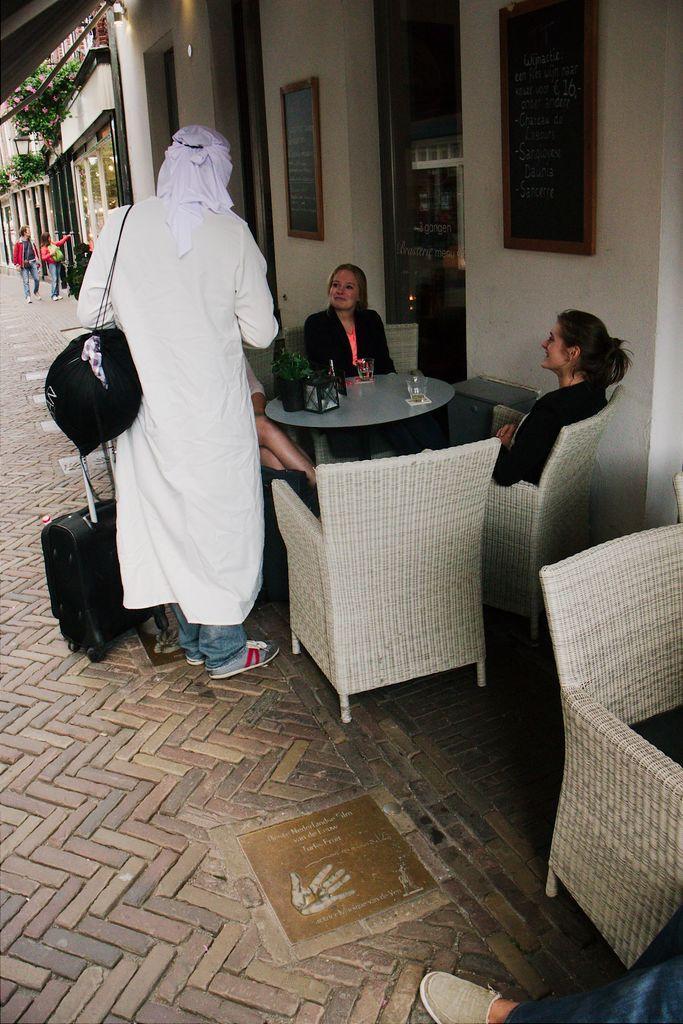In one or two sentences, can you explain what this image depicts? In this image there are four members. On the right side one girl is sitting and smiling and on the middle of the image one girl is sitting and smiling and on the left side one person is standing. On the background there is one plant and there is one street light on the left side of the top corner there are two persons walking over the street. And there is one table and four chairs, a glass is there on the table and one camera. 